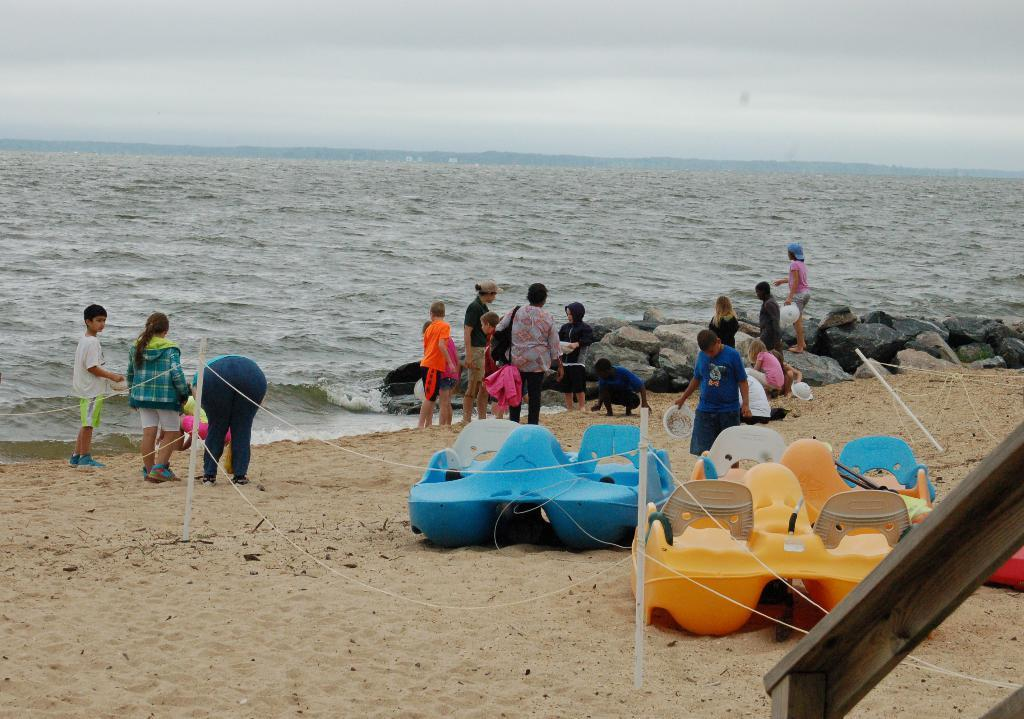Who or what is present in the image? There are people in the image. What objects can be seen in the image? There are rods, boats, and rocks visible in the image. What natural elements are present in the image? There is water, soil, and sky visible in the image. What type of coal can be seen in the image? There is no coal present in the image. What is the desire of the people in the image? The image does not provide information about the desires of the people; it only shows their presence and the objects around them. 